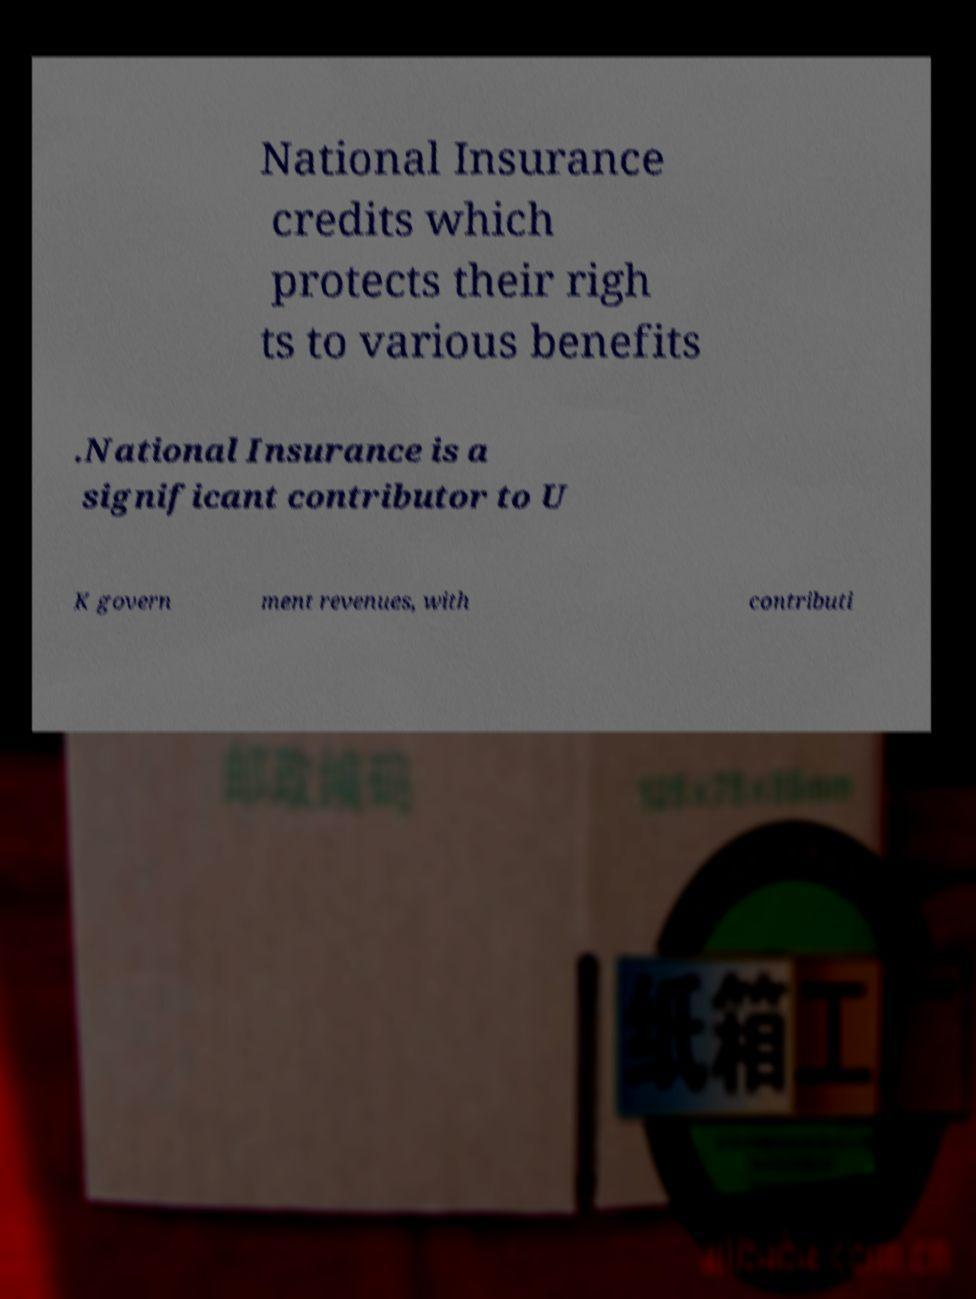Could you extract and type out the text from this image? National Insurance credits which protects their righ ts to various benefits .National Insurance is a significant contributor to U K govern ment revenues, with contributi 